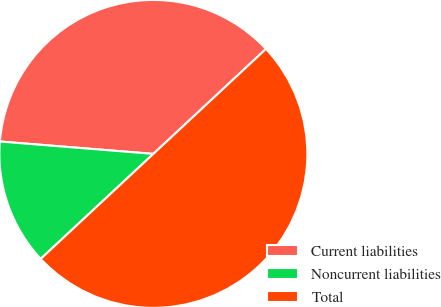Convert chart. <chart><loc_0><loc_0><loc_500><loc_500><pie_chart><fcel>Current liabilities<fcel>Noncurrent liabilities<fcel>Total<nl><fcel>36.78%<fcel>13.22%<fcel>50.0%<nl></chart> 